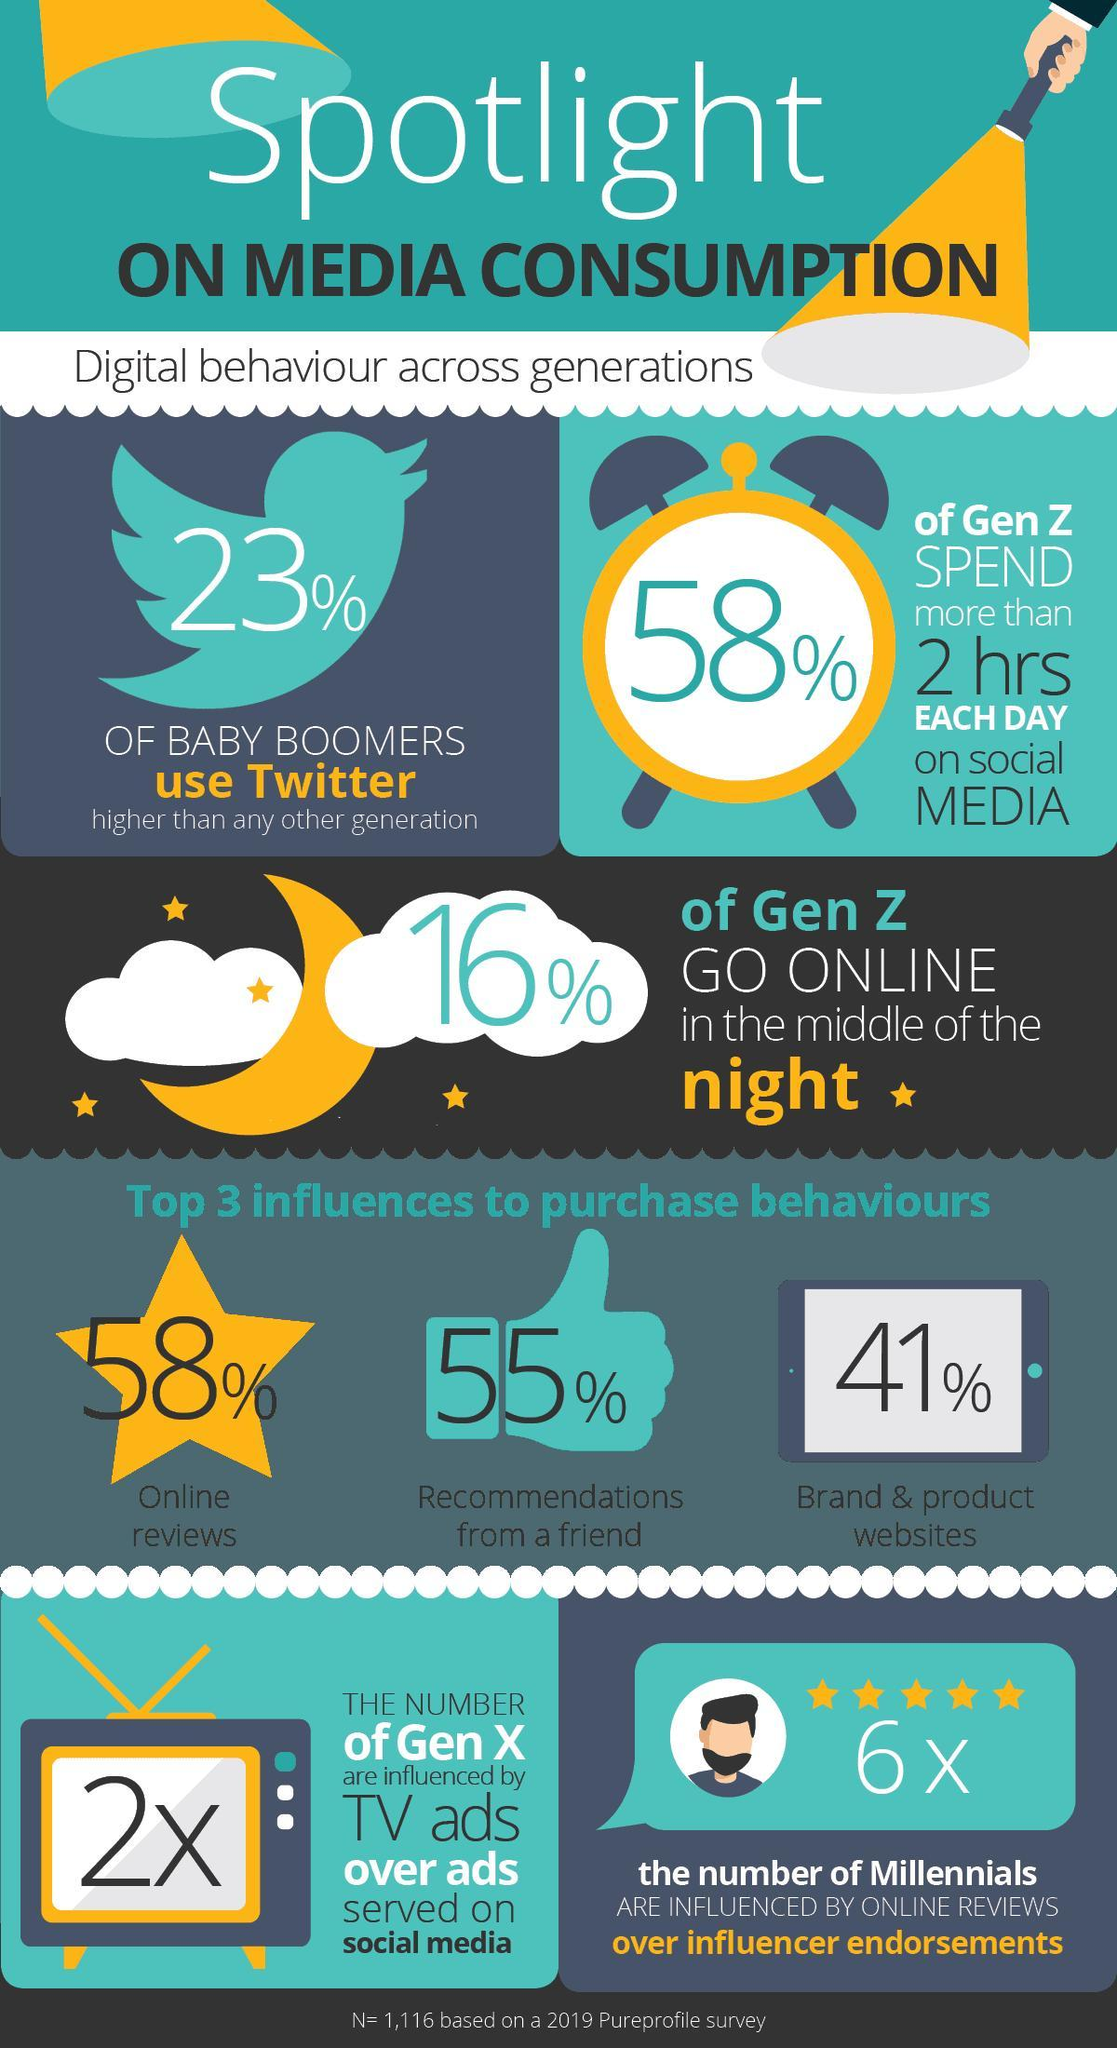what is the second most factor that influence the online purchase behaviour?
Answer the question with a short phrase. recommendations from a friend what is the second least factor that influence the online purchase behaviour? recommendations from a friend 